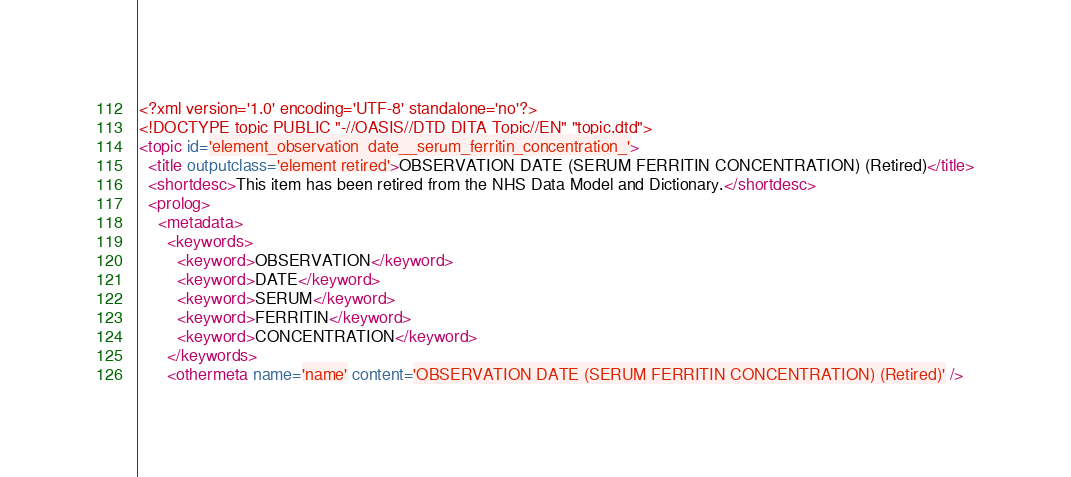Convert code to text. <code><loc_0><loc_0><loc_500><loc_500><_XML_><?xml version='1.0' encoding='UTF-8' standalone='no'?>
<!DOCTYPE topic PUBLIC "-//OASIS//DTD DITA Topic//EN" "topic.dtd">
<topic id='element_observation_date__serum_ferritin_concentration_'>
  <title outputclass='element retired'>OBSERVATION DATE (SERUM FERRITIN CONCENTRATION) (Retired)</title>
  <shortdesc>This item has been retired from the NHS Data Model and Dictionary.</shortdesc>
  <prolog>
    <metadata>
      <keywords>
        <keyword>OBSERVATION</keyword>
        <keyword>DATE</keyword>
        <keyword>SERUM</keyword>
        <keyword>FERRITIN</keyword>
        <keyword>CONCENTRATION</keyword>
      </keywords>
      <othermeta name='name' content='OBSERVATION DATE (SERUM FERRITIN CONCENTRATION) (Retired)' /></code> 